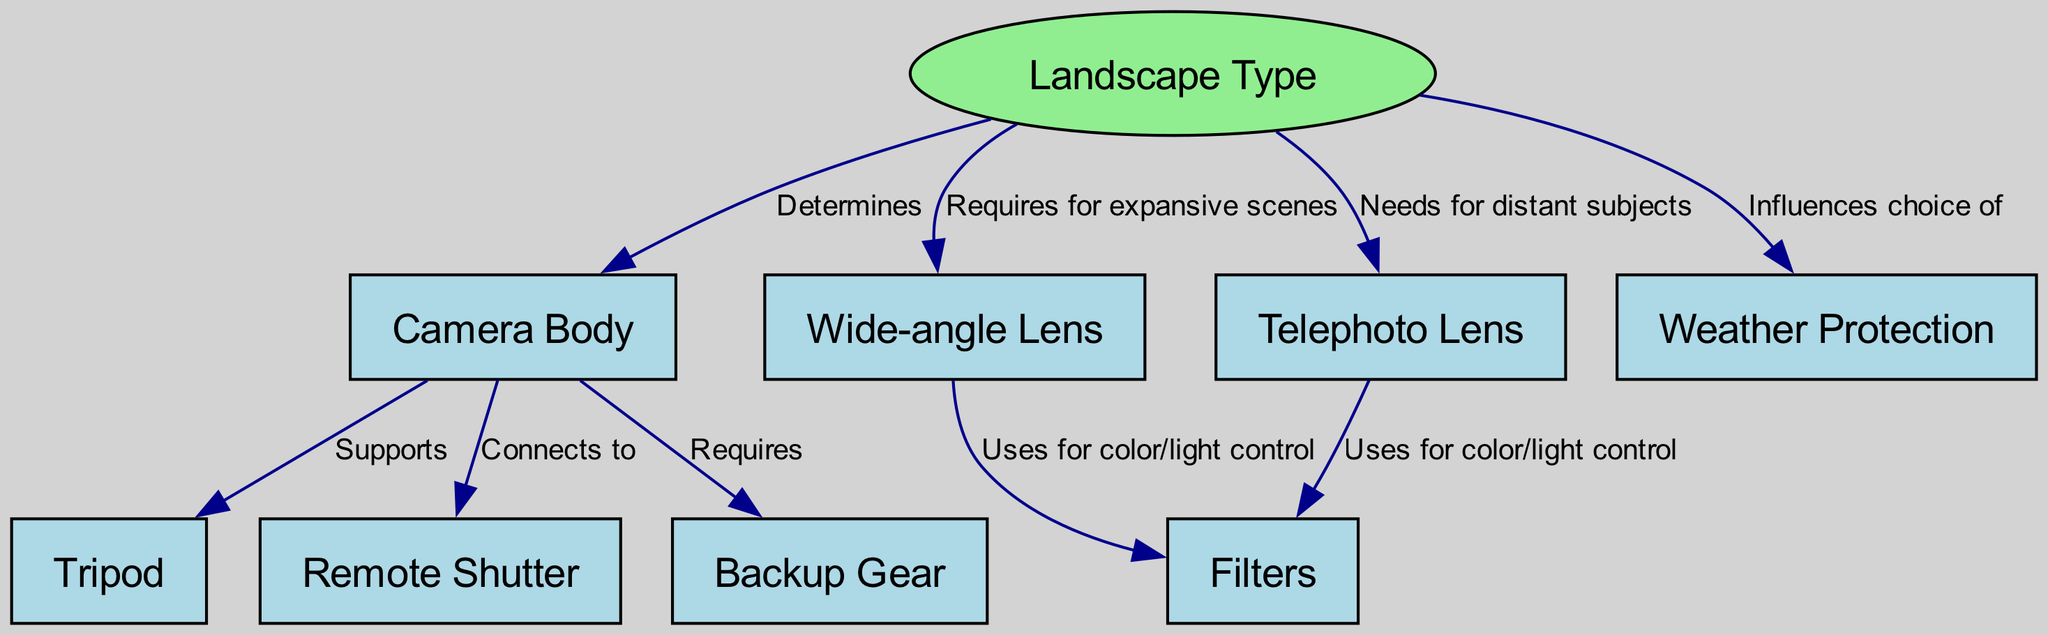What is the total number of nodes in the diagram? The diagram contains multiple nodes including "Landscape Type," "Camera Body," "Wide-angle Lens," "Telephoto Lens," "Tripod," "Filters," "Remote Shutter," "Weather Protection," and "Backup Gear." Counting these, we find a total of nine nodes.
Answer: 9 Which lens is required for expansive scenes? The diagram indicates that "Wide-angle Lens" is needed for expansive scenes as it directly connects to "Landscape Type" and specifies a requirement in this context.
Answer: Wide-angle Lens What does the "Camera Body" connect to? "Camera Body" has direct connections to "Tripod," "Remote Shutter," and "Backup Gear," as indicated by the edges leading from "Camera Body" to these nodes.
Answer: Tripod, Remote Shutter, Backup Gear How many edges are related to weather protection? The edge from "Landscape Type" to "Weather Protection" suggests that weather protection is influenced by the type of landscape being photographed, which counts as one edge related to weather protection in the diagram.
Answer: 1 Which piece of equipment uses filters for color/light control? Both "Wide-angle Lens" and "Telephoto Lens" use filters for color/light control, as illustrated by separate edges leading from each lens to the "Filters" node in the diagram.
Answer: Wide-angle Lens, Telephoto Lens What influences the choice of weather protection? The diagram shows that the "Landscape Type" influences the choice of "Weather Protection," establishing a direct relationship indicating that different landscapes may require different considerations for weather protection.
Answer: Landscape Type Which item supports the camera body? "Tripod" is the item that supports the "Camera Body," as shown by the directed edge from "Camera Body" to "Tripod."
Answer: Tripod Which two types of lenses are mentioned in the diagram? The diagram explicitly lists "Wide-angle Lens" and "Telephoto Lens" as the two types of lenses that are needed depending on the photography needs, shown by direct connections to "Landscape Type."
Answer: Wide-angle Lens, Telephoto Lens What is the main factor that determines the camera body selection? The main factor determining the selection of the "Camera Body" is the "Landscape Type," as indicated by the directed edge from "Landscape Type" to "Camera Body."
Answer: Landscape Type 